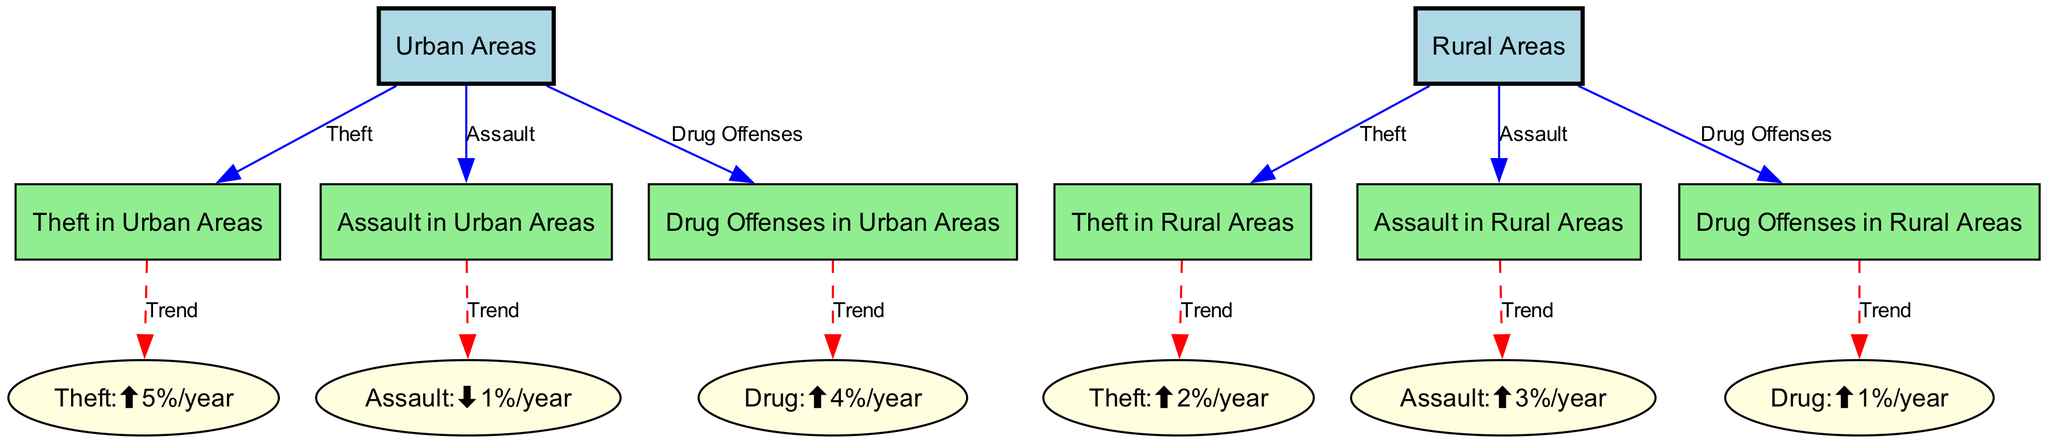What is the trend for theft in urban areas? The diagram indicates that theft in urban areas has been trending upward, specifically by 5% per year, as highlighted in the Theft:⬆5%/year node.
Answer: 5%/year What is the trend for drug offenses in rural areas? The diagram shows that drug offenses in rural areas are experiencing an increase, with a specific trend of 1% per year noted in the Drug:⬆1%/year node.
Answer: 1%/year How many types of offenses are represented in the diagram? The diagram depicts three distinct types of offenses: Theft, Assault, and Drug Offenses. Each type is connected to both urban and rural areas.
Answer: three What is the trend for assault in rural areas? According to the diagram, assault in rural areas is on the rise at a rate of 3% per year as noted in the Assault:⬆3%/year node.
Answer: 3%/year Which area has a higher increase in theft rates? The diagram illustrates that urban areas have a higher theft increase rate of 5% per year compared to the rural areas, which have a 2% increase.
Answer: urban areas Compare the trends of assault in urban versus rural areas. The urban area’s assault trend shows a decrease of 1% per year, while the rural area shows an increase of 3% per year, highlighting a contrasting trend between the two regions.
Answer: urban: -1%, rural: +3% What offense has the highest annual increase rate in urban areas? The diagram indicates that drug offenses in urban areas have the highest annual increase rate at 4%, as shown in the Drug:⬆4%/year node.
Answer: drug offenses Which offense in rural areas has a downward trend? The diagram shows no downward trend for any offense in rural areas; all presented offenses are either stable or increasing.
Answer: none 